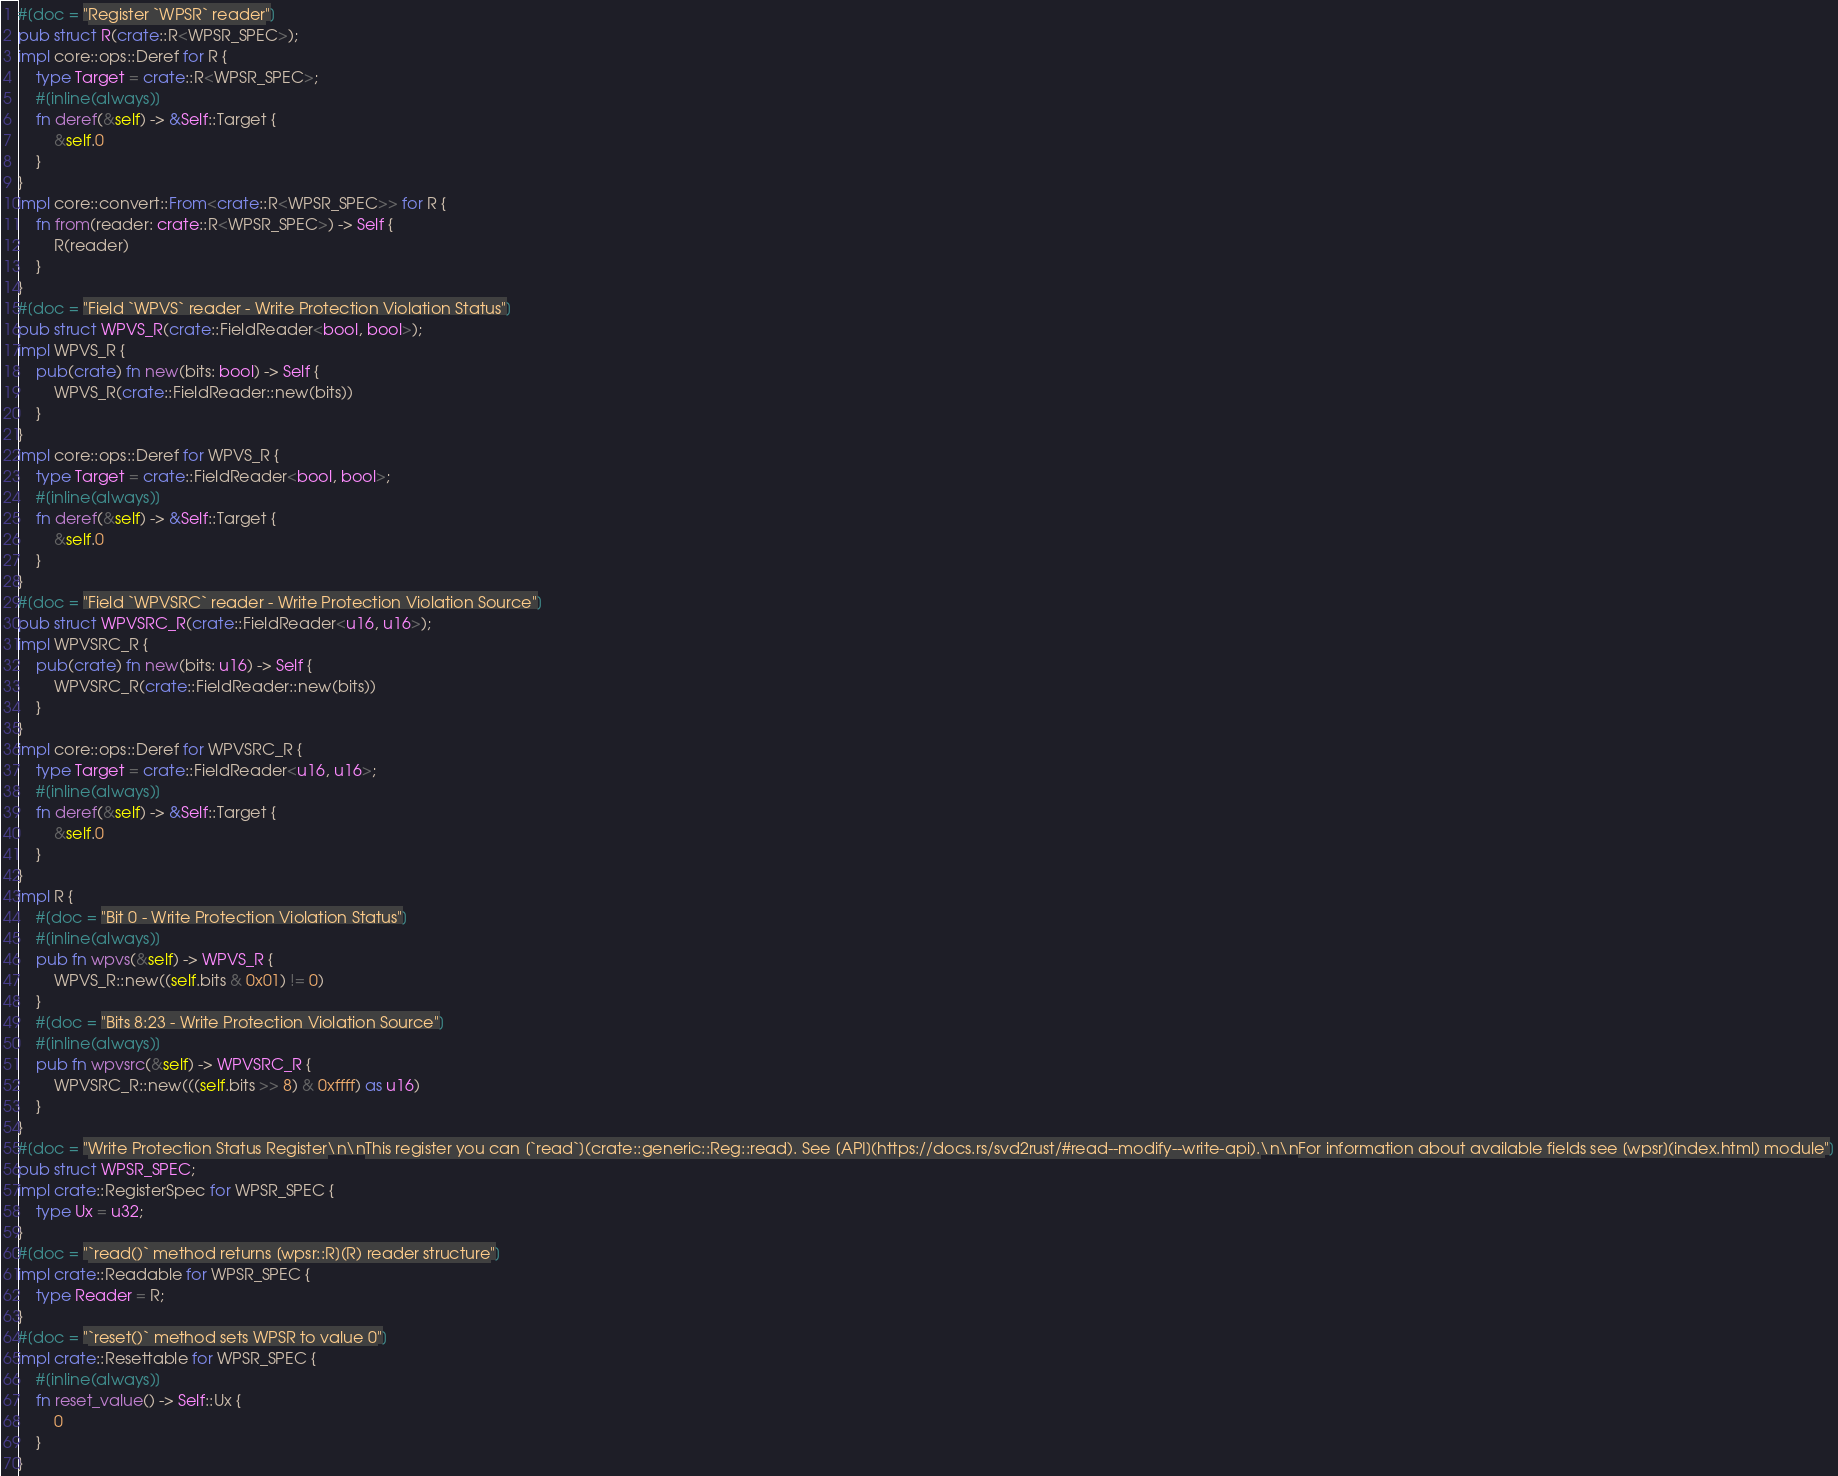Convert code to text. <code><loc_0><loc_0><loc_500><loc_500><_Rust_>#[doc = "Register `WPSR` reader"]
pub struct R(crate::R<WPSR_SPEC>);
impl core::ops::Deref for R {
    type Target = crate::R<WPSR_SPEC>;
    #[inline(always)]
    fn deref(&self) -> &Self::Target {
        &self.0
    }
}
impl core::convert::From<crate::R<WPSR_SPEC>> for R {
    fn from(reader: crate::R<WPSR_SPEC>) -> Self {
        R(reader)
    }
}
#[doc = "Field `WPVS` reader - Write Protection Violation Status"]
pub struct WPVS_R(crate::FieldReader<bool, bool>);
impl WPVS_R {
    pub(crate) fn new(bits: bool) -> Self {
        WPVS_R(crate::FieldReader::new(bits))
    }
}
impl core::ops::Deref for WPVS_R {
    type Target = crate::FieldReader<bool, bool>;
    #[inline(always)]
    fn deref(&self) -> &Self::Target {
        &self.0
    }
}
#[doc = "Field `WPVSRC` reader - Write Protection Violation Source"]
pub struct WPVSRC_R(crate::FieldReader<u16, u16>);
impl WPVSRC_R {
    pub(crate) fn new(bits: u16) -> Self {
        WPVSRC_R(crate::FieldReader::new(bits))
    }
}
impl core::ops::Deref for WPVSRC_R {
    type Target = crate::FieldReader<u16, u16>;
    #[inline(always)]
    fn deref(&self) -> &Self::Target {
        &self.0
    }
}
impl R {
    #[doc = "Bit 0 - Write Protection Violation Status"]
    #[inline(always)]
    pub fn wpvs(&self) -> WPVS_R {
        WPVS_R::new((self.bits & 0x01) != 0)
    }
    #[doc = "Bits 8:23 - Write Protection Violation Source"]
    #[inline(always)]
    pub fn wpvsrc(&self) -> WPVSRC_R {
        WPVSRC_R::new(((self.bits >> 8) & 0xffff) as u16)
    }
}
#[doc = "Write Protection Status Register\n\nThis register you can [`read`](crate::generic::Reg::read). See [API](https://docs.rs/svd2rust/#read--modify--write-api).\n\nFor information about available fields see [wpsr](index.html) module"]
pub struct WPSR_SPEC;
impl crate::RegisterSpec for WPSR_SPEC {
    type Ux = u32;
}
#[doc = "`read()` method returns [wpsr::R](R) reader structure"]
impl crate::Readable for WPSR_SPEC {
    type Reader = R;
}
#[doc = "`reset()` method sets WPSR to value 0"]
impl crate::Resettable for WPSR_SPEC {
    #[inline(always)]
    fn reset_value() -> Self::Ux {
        0
    }
}
</code> 